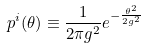Convert formula to latex. <formula><loc_0><loc_0><loc_500><loc_500>p ^ { i } ( { \theta } ) \equiv \frac { 1 } { 2 \pi g ^ { 2 } } e ^ { - \frac { \theta ^ { 2 } } { 2 g ^ { 2 } } }</formula> 